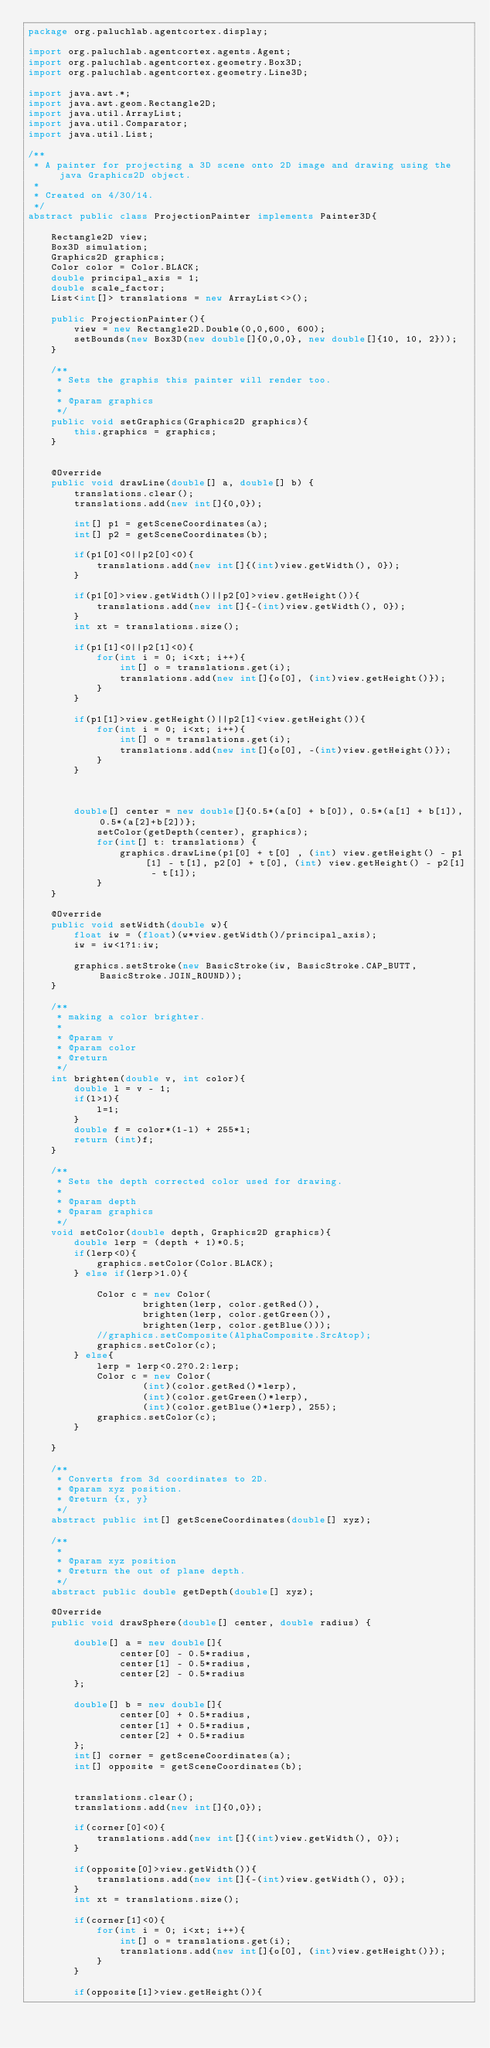<code> <loc_0><loc_0><loc_500><loc_500><_Java_>package org.paluchlab.agentcortex.display;

import org.paluchlab.agentcortex.agents.Agent;
import org.paluchlab.agentcortex.geometry.Box3D;
import org.paluchlab.agentcortex.geometry.Line3D;

import java.awt.*;
import java.awt.geom.Rectangle2D;
import java.util.ArrayList;
import java.util.Comparator;
import java.util.List;

/**
 * A painter for projecting a 3D scene onto 2D image and drawing using the java Graphics2D object.
 *
 * Created on 4/30/14.
 */
abstract public class ProjectionPainter implements Painter3D{

    Rectangle2D view;
    Box3D simulation;
    Graphics2D graphics;
    Color color = Color.BLACK;
    double principal_axis = 1;
    double scale_factor;
    List<int[]> translations = new ArrayList<>();

    public ProjectionPainter(){
        view = new Rectangle2D.Double(0,0,600, 600);
        setBounds(new Box3D(new double[]{0,0,0}, new double[]{10, 10, 2}));
    }

    /**
     * Sets the graphis this painter will render too.
     *
     * @param graphics
     */
    public void setGraphics(Graphics2D graphics){
        this.graphics = graphics;
    }


    @Override
    public void drawLine(double[] a, double[] b) {
        translations.clear();
        translations.add(new int[]{0,0});

        int[] p1 = getSceneCoordinates(a);
        int[] p2 = getSceneCoordinates(b);

        if(p1[0]<0||p2[0]<0){
            translations.add(new int[]{(int)view.getWidth(), 0});
        }

        if(p1[0]>view.getWidth()||p2[0]>view.getHeight()){
            translations.add(new int[]{-(int)view.getWidth(), 0});
        }
        int xt = translations.size();

        if(p1[1]<0||p2[1]<0){
            for(int i = 0; i<xt; i++){
                int[] o = translations.get(i);
                translations.add(new int[]{o[0], (int)view.getHeight()});
            }
        }

        if(p1[1]>view.getHeight()||p2[1]<view.getHeight()){
            for(int i = 0; i<xt; i++){
                int[] o = translations.get(i);
                translations.add(new int[]{o[0], -(int)view.getHeight()});
            }
        }



        double[] center = new double[]{0.5*(a[0] + b[0]), 0.5*(a[1] + b[1]), 0.5*(a[2]+b[2])};
            setColor(getDepth(center), graphics);
            for(int[] t: translations) {
                graphics.drawLine(p1[0] + t[0] , (int) view.getHeight() - p1[1] - t[1], p2[0] + t[0], (int) view.getHeight() - p2[1] - t[1]);
            }
    }

    @Override
    public void setWidth(double w){
        float iw = (float)(w*view.getWidth()/principal_axis);
        iw = iw<1?1:iw;

        graphics.setStroke(new BasicStroke(iw, BasicStroke.CAP_BUTT, BasicStroke.JOIN_ROUND));
    }

    /**
     * making a color brighter.
     *
     * @param v
     * @param color
     * @return
     */
    int brighten(double v, int color){
        double l = v - 1;
        if(l>1){
            l=1;
        }
        double f = color*(1-l) + 255*l;
        return (int)f;
    }

    /**
     * Sets the depth corrected color used for drawing.
     *
     * @param depth
     * @param graphics
     */
    void setColor(double depth, Graphics2D graphics){
        double lerp = (depth + 1)*0.5;
        if(lerp<0){
            graphics.setColor(Color.BLACK);
        } else if(lerp>1.0){

            Color c = new Color(
                    brighten(lerp, color.getRed()),
                    brighten(lerp, color.getGreen()),
                    brighten(lerp, color.getBlue()));
            //graphics.setComposite(AlphaComposite.SrcAtop);
            graphics.setColor(c);
        } else{
            lerp = lerp<0.2?0.2:lerp;
            Color c = new Color(
                    (int)(color.getRed()*lerp),
                    (int)(color.getGreen()*lerp),
                    (int)(color.getBlue()*lerp), 255);
            graphics.setColor(c);
        }

    }

    /**
     * Converts from 3d coordinates to 2D.
     * @param xyz position.
     * @return {x, y}
     */
    abstract public int[] getSceneCoordinates(double[] xyz);

    /**
     *
     * @param xyz position
     * @return the out of plane depth.
     */
    abstract public double getDepth(double[] xyz);

    @Override
    public void drawSphere(double[] center, double radius) {

        double[] a = new double[]{
                center[0] - 0.5*radius,
                center[1] - 0.5*radius,
                center[2] - 0.5*radius
        };

        double[] b = new double[]{
                center[0] + 0.5*radius,
                center[1] + 0.5*radius,
                center[2] + 0.5*radius
        };
        int[] corner = getSceneCoordinates(a);
        int[] opposite = getSceneCoordinates(b);


        translations.clear();
        translations.add(new int[]{0,0});

        if(corner[0]<0){
            translations.add(new int[]{(int)view.getWidth(), 0});
        }

        if(opposite[0]>view.getWidth()){
            translations.add(new int[]{-(int)view.getWidth(), 0});
        }
        int xt = translations.size();

        if(corner[1]<0){
            for(int i = 0; i<xt; i++){
                int[] o = translations.get(i);
                translations.add(new int[]{o[0], (int)view.getHeight()});
            }
        }

        if(opposite[1]>view.getHeight()){</code> 